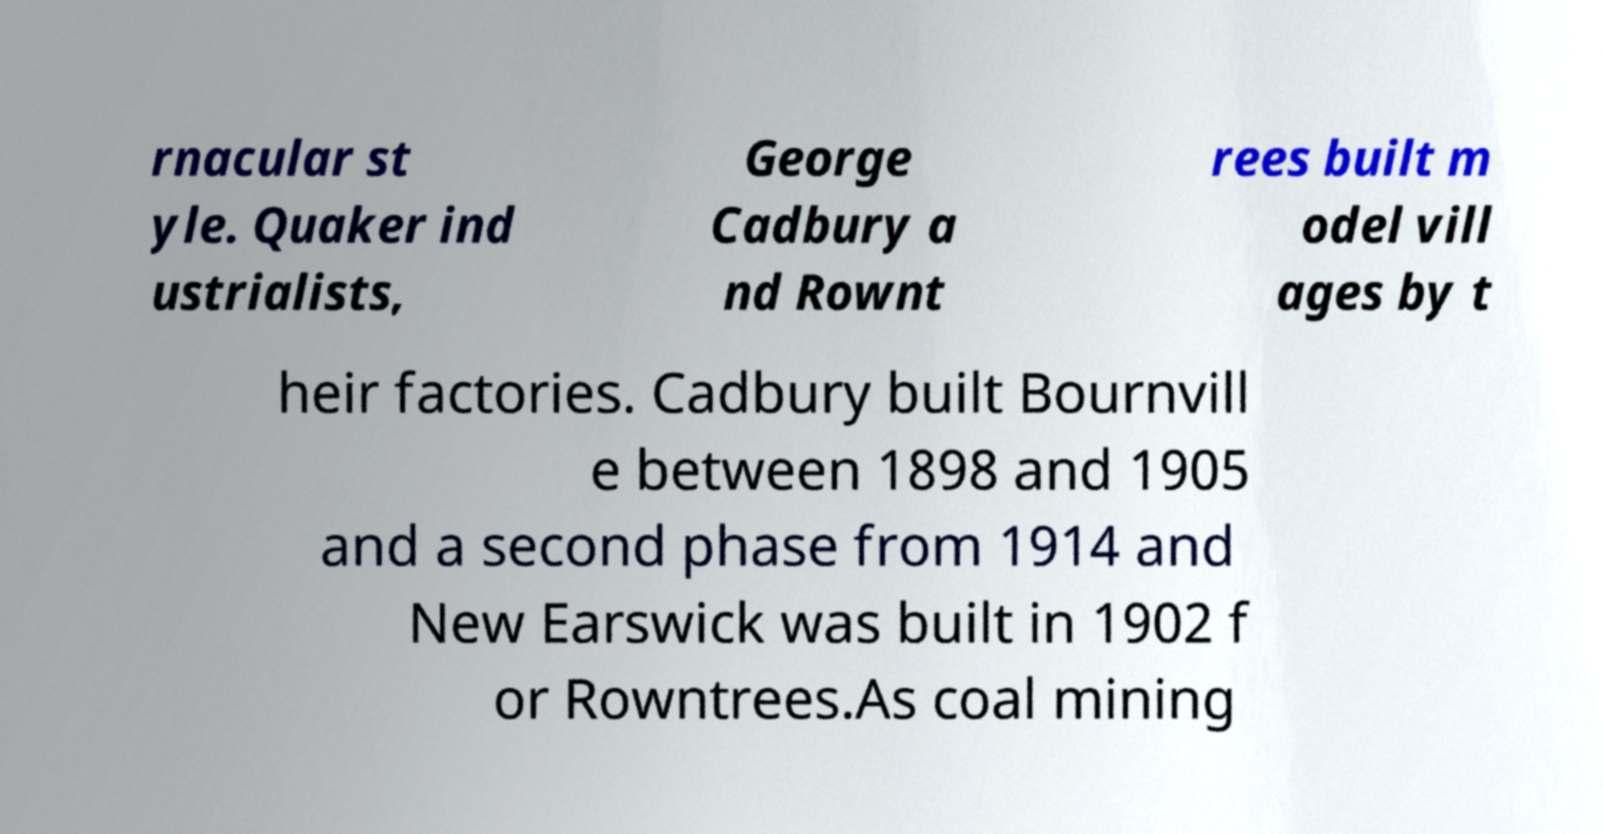Can you read and provide the text displayed in the image?This photo seems to have some interesting text. Can you extract and type it out for me? rnacular st yle. Quaker ind ustrialists, George Cadbury a nd Rownt rees built m odel vill ages by t heir factories. Cadbury built Bournvill e between 1898 and 1905 and a second phase from 1914 and New Earswick was built in 1902 f or Rowntrees.As coal mining 